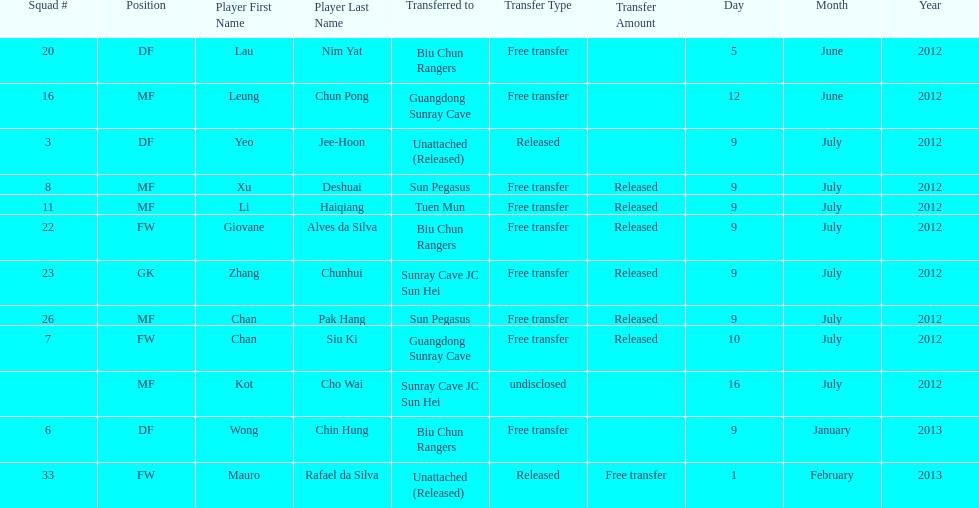Give me the full table as a dictionary. {'header': ['Squad #', 'Position', 'Player First Name', 'Player Last Name', 'Transferred to', 'Transfer Type', 'Transfer Amount', 'Day', 'Month', 'Year'], 'rows': [['20', 'DF', 'Lau', 'Nim Yat', 'Biu Chun Rangers', 'Free transfer', '', '5', 'June', '2012'], ['16', 'MF', 'Leung', 'Chun Pong', 'Guangdong Sunray Cave', 'Free transfer', '', '12', 'June', '2012'], ['3', 'DF', 'Yeo', 'Jee-Hoon', 'Unattached (Released)', 'Released', '', '9', 'July', '2012'], ['8', 'MF', 'Xu', 'Deshuai', 'Sun Pegasus', 'Free transfer', 'Released', '9', 'July', '2012'], ['11', 'MF', 'Li', 'Haiqiang', 'Tuen Mun', 'Free transfer', 'Released', '9', 'July', '2012'], ['22', 'FW', 'Giovane', 'Alves da Silva', 'Biu Chun Rangers', 'Free transfer', 'Released', '9', 'July', '2012'], ['23', 'GK', 'Zhang', 'Chunhui', 'Sunray Cave JC Sun Hei', 'Free transfer', 'Released', '9', 'July', '2012'], ['26', 'MF', 'Chan', 'Pak Hang', 'Sun Pegasus', 'Free transfer', 'Released', '9', 'July', '2012'], ['7', 'FW', 'Chan', 'Siu Ki', 'Guangdong Sunray Cave', 'Free transfer', 'Released', '10', 'July', '2012'], ['', 'MF', 'Kot', 'Cho Wai', 'Sunray Cave JC Sun Hei', 'undisclosed', '', '16', 'July', '2012'], ['6', 'DF', 'Wong', 'Chin Hung', 'Biu Chun Rangers', 'Free transfer', '', '9', 'January', '2013'], ['33', 'FW', 'Mauro', 'Rafael da Silva', 'Unattached (Released)', 'Released', 'Free transfer', '1', 'February', '2013']]} Li haiqiang and xu deshuai both played which position? MF. 